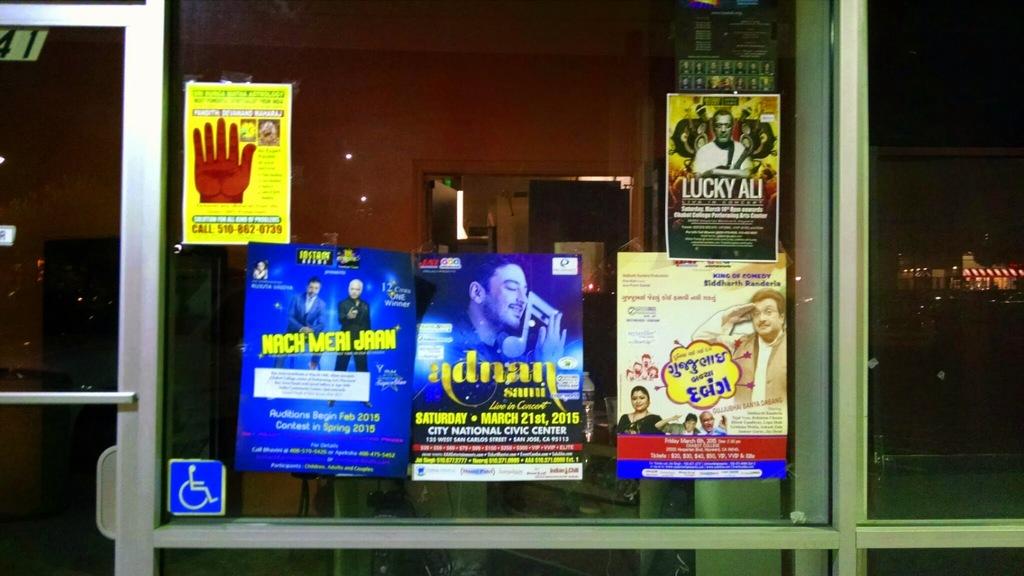What is in yellow letters on the sign on the left?
Offer a very short reply. Nach meri jaan. What is the movie name of the top right corner?
Provide a succinct answer. Lucky ali. 